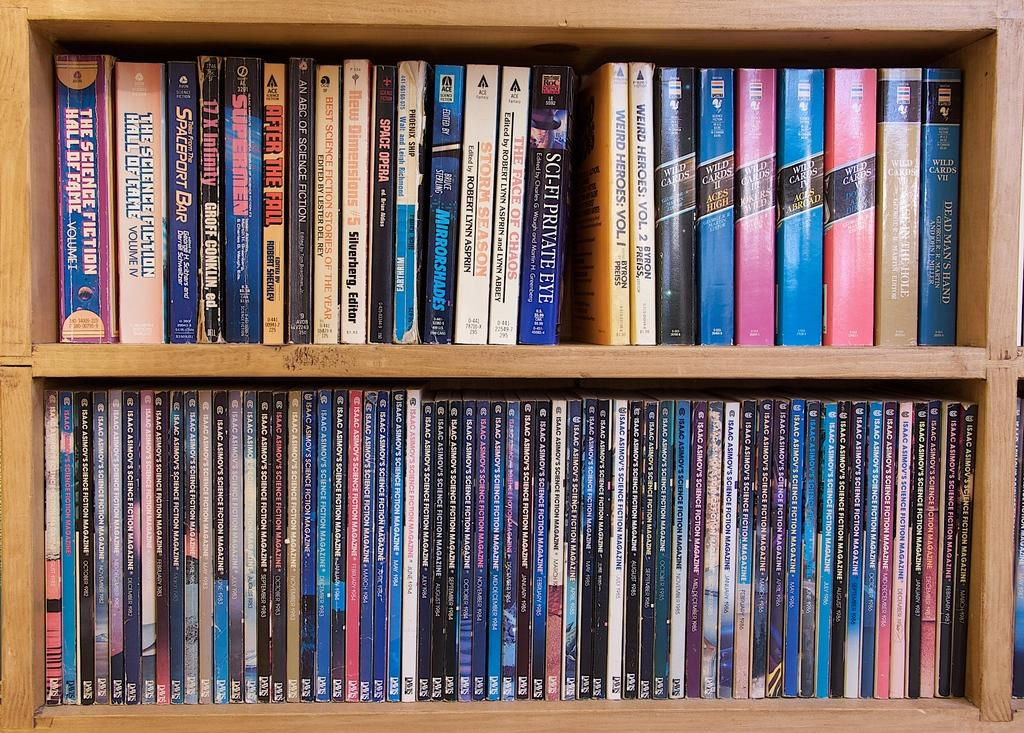What type of furniture is present in the image? There is a wooden shelf unit in the image. What is the purpose of the wooden shelf unit? The wooden shelf unit is full of books, suggesting it is used for storage and organization. What caption is written on the books in the image? There is no caption written on the books in the image; the provided facts only mention that the shelf unit is full of books. 